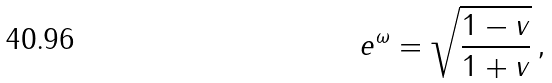<formula> <loc_0><loc_0><loc_500><loc_500>e ^ { \omega } = \sqrt { \frac { 1 - v } { 1 + v } } \, ,</formula> 